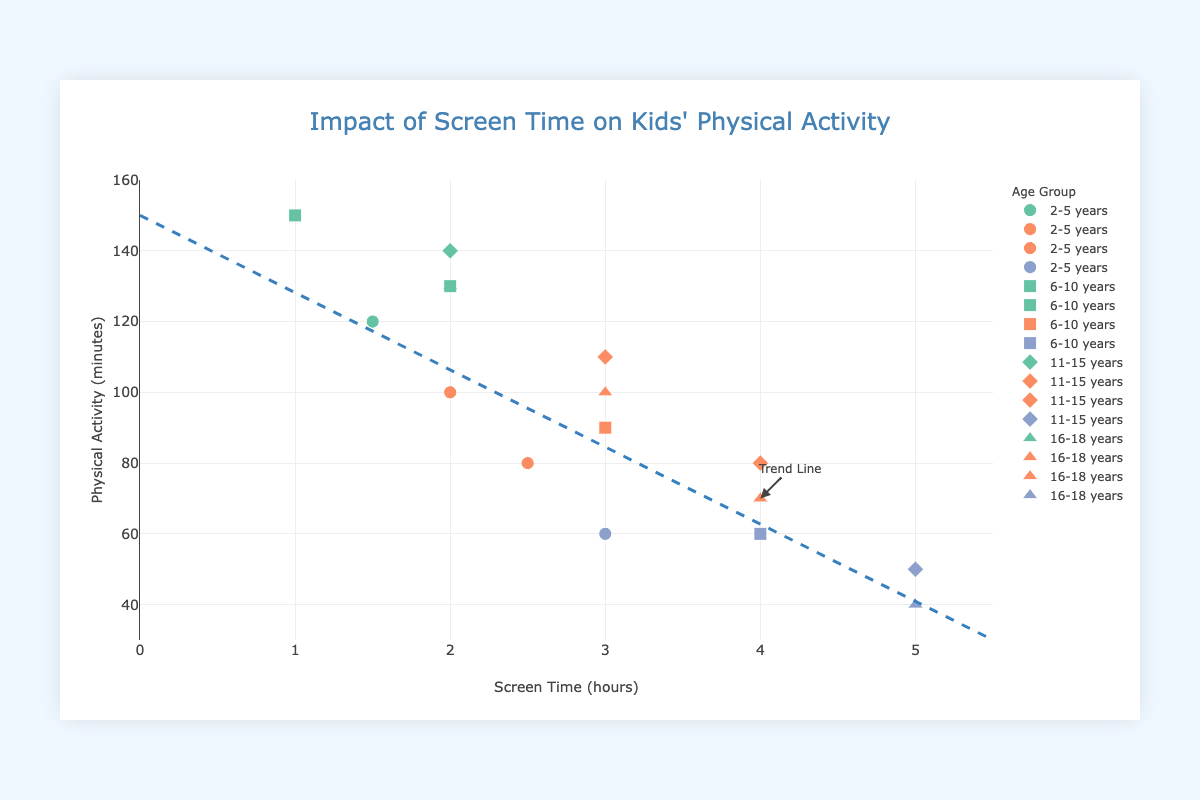How many data points are represented on the plot for the "11-15 years" age group? There are four data points for the "11-15 years" age group. You can count the markers associated with the diamond shapes and check their labels.
Answer: 4 What is the title of the scatter plot? The title is found at the top of the plot.
Answer: Impact of Screen Time on Kids' Physical Activity Which age group shows the highest screen time? By observing the markers and their labels, you can identify that the "11-15 years" and "16-18 years" age groups both have data points reaching 5.0 hours of screen time.
Answer: 11-15 years and 16-18 years What is the screen time and physical activity for the "6-10 years" age group with the health outcome "Overweight"? You can look at markers with the corresponding age group (square shape) and health outcome (orange color). Here, it shows a screen time of 3.0 hours and physical activity of 90 minutes.
Answer: 3.0 hours and 90 minutes Compare the physical activity levels between "2-5 years" and "16-18 years" age groups for the same screen time of 2.0 hours. By observing both age groups' (circle and triangle-up shapes) markers at 2.0 hours of screen time, the physical activity is 100 minutes for "2-5 years" and 130 minutes for "16-18 years".
Answer: "16-18 years" has higher physical activity levels What color represents the "Normal weight" health outcome? By observing the key, the color associated with "Normal weight" is the green shade.
Answer: Green How does physical activity change as screen time increases? As screen time increases, physical activity generally decreases. This is observable from the trend line which slopes downwards from high to low physical activity levels.
Answer: Decreases Is there an outlier where an age group shows high physical activity for high screen time? No, all data points align well with the trend that high screen time corresponds to low physical activity levels.
Answer: No What is the general trend between screen time and physical activity among kids? The trend line shows that as screen time increases, physical activity decreases. This trend is consistent across all age groups.
Answer: Screen time increases, physical activity decreases Which age group shows the least physical activity at the highest screen time? By observing the plot, the "16-18 years" age group (triangle-up) has the least physical activity (40 minutes) at the highest screen time (5.0 hours).
Answer: 16-18 years 